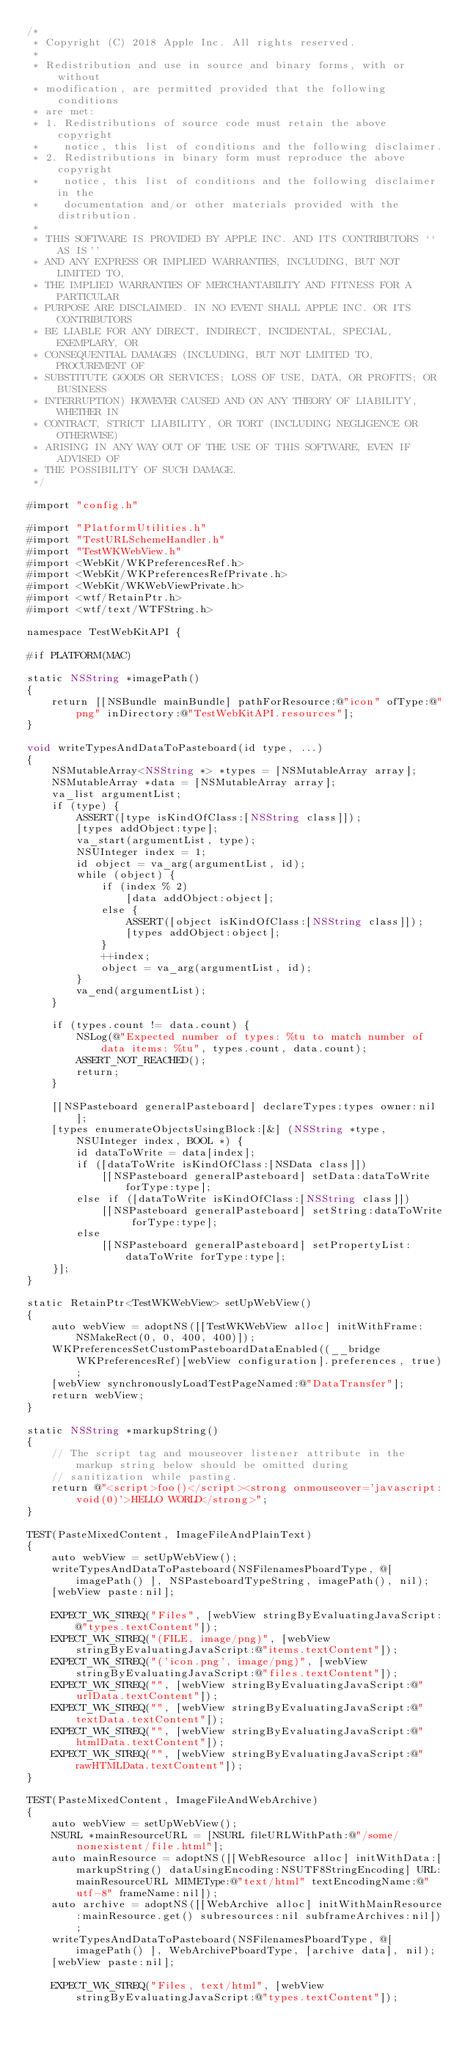<code> <loc_0><loc_0><loc_500><loc_500><_ObjectiveC_>/*
 * Copyright (C) 2018 Apple Inc. All rights reserved.
 *
 * Redistribution and use in source and binary forms, with or without
 * modification, are permitted provided that the following conditions
 * are met:
 * 1. Redistributions of source code must retain the above copyright
 *    notice, this list of conditions and the following disclaimer.
 * 2. Redistributions in binary form must reproduce the above copyright
 *    notice, this list of conditions and the following disclaimer in the
 *    documentation and/or other materials provided with the distribution.
 *
 * THIS SOFTWARE IS PROVIDED BY APPLE INC. AND ITS CONTRIBUTORS ``AS IS''
 * AND ANY EXPRESS OR IMPLIED WARRANTIES, INCLUDING, BUT NOT LIMITED TO,
 * THE IMPLIED WARRANTIES OF MERCHANTABILITY AND FITNESS FOR A PARTICULAR
 * PURPOSE ARE DISCLAIMED. IN NO EVENT SHALL APPLE INC. OR ITS CONTRIBUTORS
 * BE LIABLE FOR ANY DIRECT, INDIRECT, INCIDENTAL, SPECIAL, EXEMPLARY, OR
 * CONSEQUENTIAL DAMAGES (INCLUDING, BUT NOT LIMITED TO, PROCUREMENT OF
 * SUBSTITUTE GOODS OR SERVICES; LOSS OF USE, DATA, OR PROFITS; OR BUSINESS
 * INTERRUPTION) HOWEVER CAUSED AND ON ANY THEORY OF LIABILITY, WHETHER IN
 * CONTRACT, STRICT LIABILITY, OR TORT (INCLUDING NEGLIGENCE OR OTHERWISE)
 * ARISING IN ANY WAY OUT OF THE USE OF THIS SOFTWARE, EVEN IF ADVISED OF
 * THE POSSIBILITY OF SUCH DAMAGE.
 */

#import "config.h"

#import "PlatformUtilities.h"
#import "TestURLSchemeHandler.h"
#import "TestWKWebView.h"
#import <WebKit/WKPreferencesRef.h>
#import <WebKit/WKPreferencesRefPrivate.h>
#import <WebKit/WKWebViewPrivate.h>
#import <wtf/RetainPtr.h>
#import <wtf/text/WTFString.h>

namespace TestWebKitAPI {

#if PLATFORM(MAC)

static NSString *imagePath()
{
    return [[NSBundle mainBundle] pathForResource:@"icon" ofType:@"png" inDirectory:@"TestWebKitAPI.resources"];
}

void writeTypesAndDataToPasteboard(id type, ...)
{
    NSMutableArray<NSString *> *types = [NSMutableArray array];
    NSMutableArray *data = [NSMutableArray array];
    va_list argumentList;
    if (type) {
        ASSERT([type isKindOfClass:[NSString class]]);
        [types addObject:type];
        va_start(argumentList, type);
        NSUInteger index = 1;
        id object = va_arg(argumentList, id);
        while (object) {
            if (index % 2)
                [data addObject:object];
            else {
                ASSERT([object isKindOfClass:[NSString class]]);
                [types addObject:object];
            }
            ++index;
            object = va_arg(argumentList, id);
        }
        va_end(argumentList);
    }

    if (types.count != data.count) {
        NSLog(@"Expected number of types: %tu to match number of data items: %tu", types.count, data.count);
        ASSERT_NOT_REACHED();
        return;
    }

    [[NSPasteboard generalPasteboard] declareTypes:types owner:nil];
    [types enumerateObjectsUsingBlock:[&] (NSString *type, NSUInteger index, BOOL *) {
        id dataToWrite = data[index];
        if ([dataToWrite isKindOfClass:[NSData class]])
            [[NSPasteboard generalPasteboard] setData:dataToWrite forType:type];
        else if ([dataToWrite isKindOfClass:[NSString class]])
            [[NSPasteboard generalPasteboard] setString:dataToWrite forType:type];
        else
            [[NSPasteboard generalPasteboard] setPropertyList:dataToWrite forType:type];
    }];
}

static RetainPtr<TestWKWebView> setUpWebView()
{
    auto webView = adoptNS([[TestWKWebView alloc] initWithFrame:NSMakeRect(0, 0, 400, 400)]);
    WKPreferencesSetCustomPasteboardDataEnabled((__bridge WKPreferencesRef)[webView configuration].preferences, true);
    [webView synchronouslyLoadTestPageNamed:@"DataTransfer"];
    return webView;
}

static NSString *markupString()
{
    // The script tag and mouseover listener attribute in the markup string below should be omitted during
    // sanitization while pasting.
    return @"<script>foo()</script><strong onmouseover='javascript:void(0)'>HELLO WORLD</strong>";
}

TEST(PasteMixedContent, ImageFileAndPlainText)
{
    auto webView = setUpWebView();
    writeTypesAndDataToPasteboard(NSFilenamesPboardType, @[ imagePath() ], NSPasteboardTypeString, imagePath(), nil);
    [webView paste:nil];

    EXPECT_WK_STREQ("Files", [webView stringByEvaluatingJavaScript:@"types.textContent"]);
    EXPECT_WK_STREQ("(FILE, image/png)", [webView stringByEvaluatingJavaScript:@"items.textContent"]);
    EXPECT_WK_STREQ("('icon.png', image/png)", [webView stringByEvaluatingJavaScript:@"files.textContent"]);
    EXPECT_WK_STREQ("", [webView stringByEvaluatingJavaScript:@"urlData.textContent"]);
    EXPECT_WK_STREQ("", [webView stringByEvaluatingJavaScript:@"textData.textContent"]);
    EXPECT_WK_STREQ("", [webView stringByEvaluatingJavaScript:@"htmlData.textContent"]);
    EXPECT_WK_STREQ("", [webView stringByEvaluatingJavaScript:@"rawHTMLData.textContent"]);
}

TEST(PasteMixedContent, ImageFileAndWebArchive)
{
    auto webView = setUpWebView();
    NSURL *mainResourceURL = [NSURL fileURLWithPath:@"/some/nonexistent/file.html"];
    auto mainResource = adoptNS([[WebResource alloc] initWithData:[markupString() dataUsingEncoding:NSUTF8StringEncoding] URL:mainResourceURL MIMEType:@"text/html" textEncodingName:@"utf-8" frameName:nil]);
    auto archive = adoptNS([[WebArchive alloc] initWithMainResource:mainResource.get() subresources:nil subframeArchives:nil]);
    writeTypesAndDataToPasteboard(NSFilenamesPboardType, @[ imagePath() ], WebArchivePboardType, [archive data], nil);
    [webView paste:nil];

    EXPECT_WK_STREQ("Files, text/html", [webView stringByEvaluatingJavaScript:@"types.textContent"]);</code> 